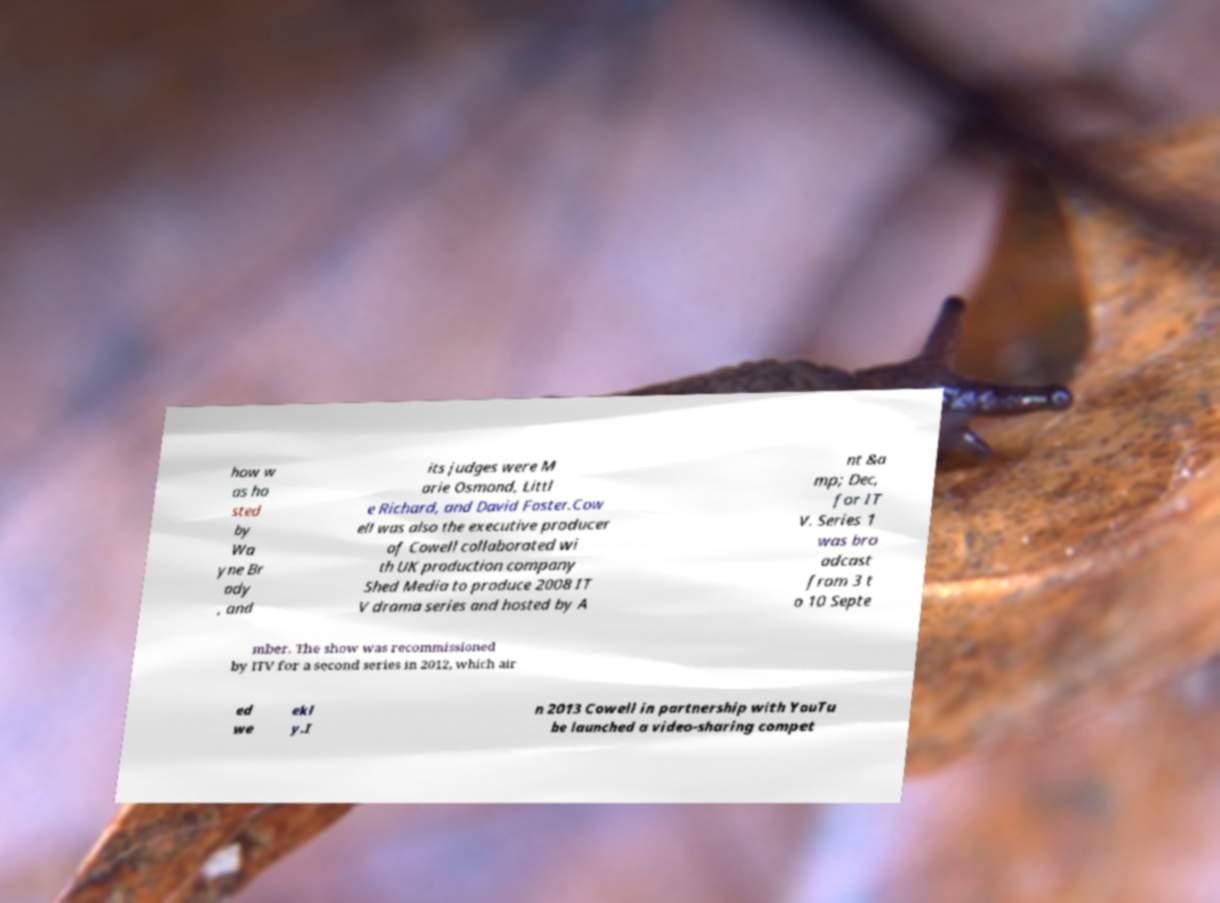There's text embedded in this image that I need extracted. Can you transcribe it verbatim? how w as ho sted by Wa yne Br ady , and its judges were M arie Osmond, Littl e Richard, and David Foster.Cow ell was also the executive producer of Cowell collaborated wi th UK production company Shed Media to produce 2008 IT V drama series and hosted by A nt &a mp; Dec, for IT V. Series 1 was bro adcast from 3 t o 10 Septe mber. The show was recommissioned by ITV for a second series in 2012, which air ed we ekl y.I n 2013 Cowell in partnership with YouTu be launched a video-sharing compet 